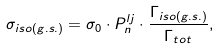Convert formula to latex. <formula><loc_0><loc_0><loc_500><loc_500>\sigma _ { i s o ( g . s . ) } = \sigma _ { 0 } \cdot P _ { n } ^ { l j } \cdot \frac { \Gamma _ { i s o ( g . s . ) } } { \Gamma _ { t o t } } ,</formula> 